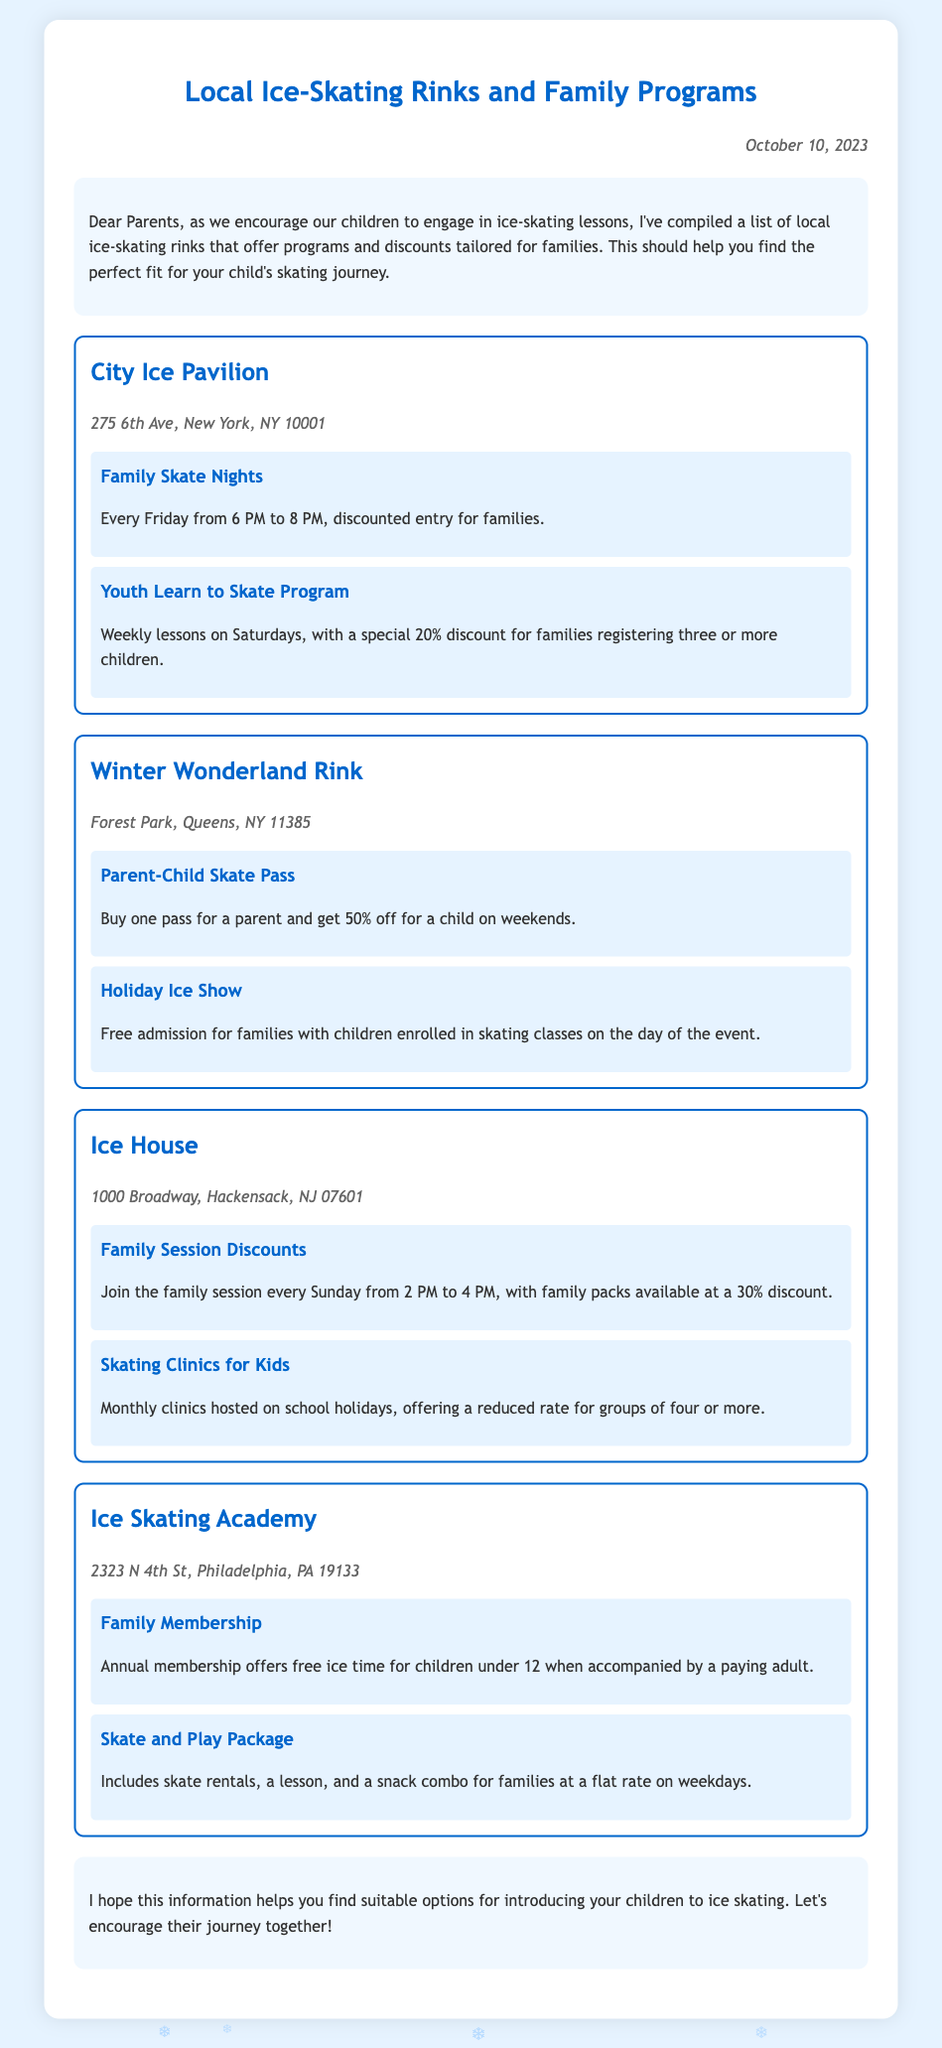What is the location of the City Ice Pavilion? The document states that the City Ice Pavilion is located at 275 6th Ave, New York, NY 10001.
Answer: 275 6th Ave, New York, NY 10001 What special discount is offered for the Youth Learn to Skate Program? The document mentions a special 20% discount for families registering three or more children in the Youth Learn to Skate Program.
Answer: 20% discount What time do Family Skate Nights take place? According to the document, Family Skate Nights occur every Friday from 6 PM to 8 PM.
Answer: 6 PM to 8 PM What program offers free admission for families during the Holiday Ice Show? The document indicates that families with children enrolled in skating classes can have free admission during the Holiday Ice Show.
Answer: Free admission for families How much is the discount for a child with a Parent-Child Skate Pass? It is stated in the document that the discount for a child is 50% off when buying a Parent-Child Skate Pass.
Answer: 50% off What is the primary audience for the skating clinics at Ice House? The document specifies that the skating clinics at Ice House are hosted for kids during school holidays.
Answer: Kids How does the Family Membership at Ice Skating Academy benefit children under 12? The document notes that children under 12 enjoy free ice time when accompanied by a paying adult as part of the Family Membership.
Answer: Free ice time Which rink offers a Skate and Play Package? According to the document, the Ice Skating Academy offers the Skate and Play Package.
Answer: Ice Skating Academy On which day do Family Session Discounts occur at Ice House? The document states that Family Session Discounts are available every Sunday from 2 PM to 4 PM.
Answer: Sunday 